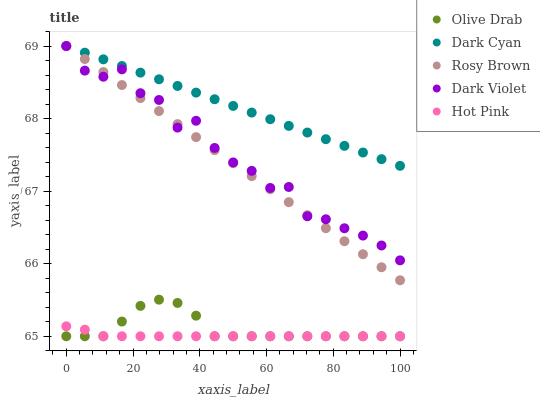Does Hot Pink have the minimum area under the curve?
Answer yes or no. Yes. Does Dark Cyan have the maximum area under the curve?
Answer yes or no. Yes. Does Rosy Brown have the minimum area under the curve?
Answer yes or no. No. Does Rosy Brown have the maximum area under the curve?
Answer yes or no. No. Is Dark Cyan the smoothest?
Answer yes or no. Yes. Is Dark Violet the roughest?
Answer yes or no. Yes. Is Rosy Brown the smoothest?
Answer yes or no. No. Is Rosy Brown the roughest?
Answer yes or no. No. Does Olive Drab have the lowest value?
Answer yes or no. Yes. Does Rosy Brown have the lowest value?
Answer yes or no. No. Does Dark Violet have the highest value?
Answer yes or no. Yes. Does Olive Drab have the highest value?
Answer yes or no. No. Is Hot Pink less than Rosy Brown?
Answer yes or no. Yes. Is Rosy Brown greater than Olive Drab?
Answer yes or no. Yes. Does Dark Cyan intersect Rosy Brown?
Answer yes or no. Yes. Is Dark Cyan less than Rosy Brown?
Answer yes or no. No. Is Dark Cyan greater than Rosy Brown?
Answer yes or no. No. Does Hot Pink intersect Rosy Brown?
Answer yes or no. No. 